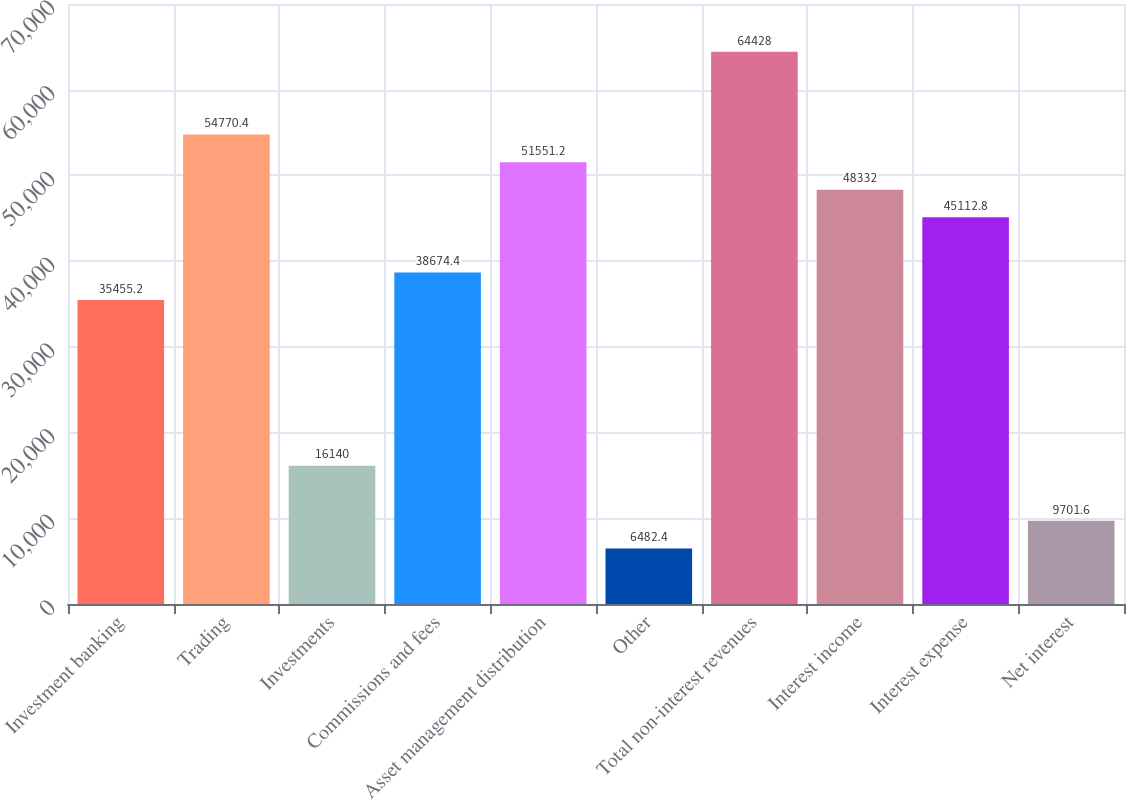<chart> <loc_0><loc_0><loc_500><loc_500><bar_chart><fcel>Investment banking<fcel>Trading<fcel>Investments<fcel>Commissions and fees<fcel>Asset management distribution<fcel>Other<fcel>Total non-interest revenues<fcel>Interest income<fcel>Interest expense<fcel>Net interest<nl><fcel>35455.2<fcel>54770.4<fcel>16140<fcel>38674.4<fcel>51551.2<fcel>6482.4<fcel>64428<fcel>48332<fcel>45112.8<fcel>9701.6<nl></chart> 